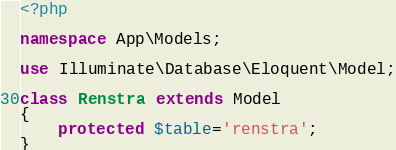Convert code to text. <code><loc_0><loc_0><loc_500><loc_500><_PHP_><?php

namespace App\Models;

use Illuminate\Database\Eloquent\Model;

class Renstra extends Model
{
    protected $table='renstra';
}
</code> 